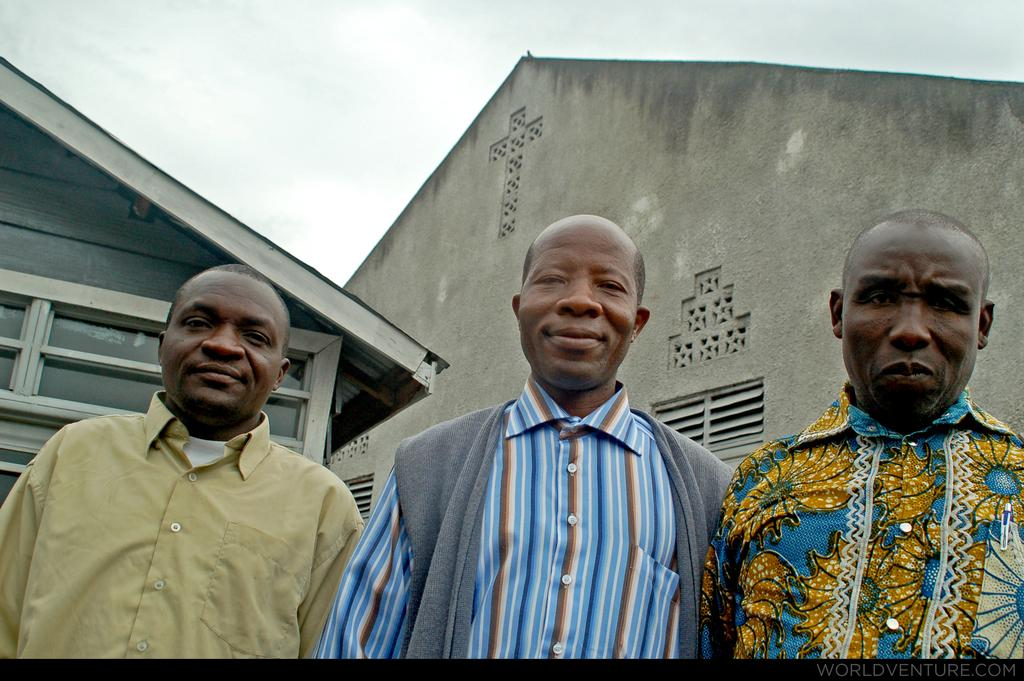How many people are present in the image? There are three men standing in the image. What can be seen in the background of the image? There is a house and the sky visible in the background of the image. What type of cake is being served on the lamp in the image? There is no cake or lamp present in the image. 